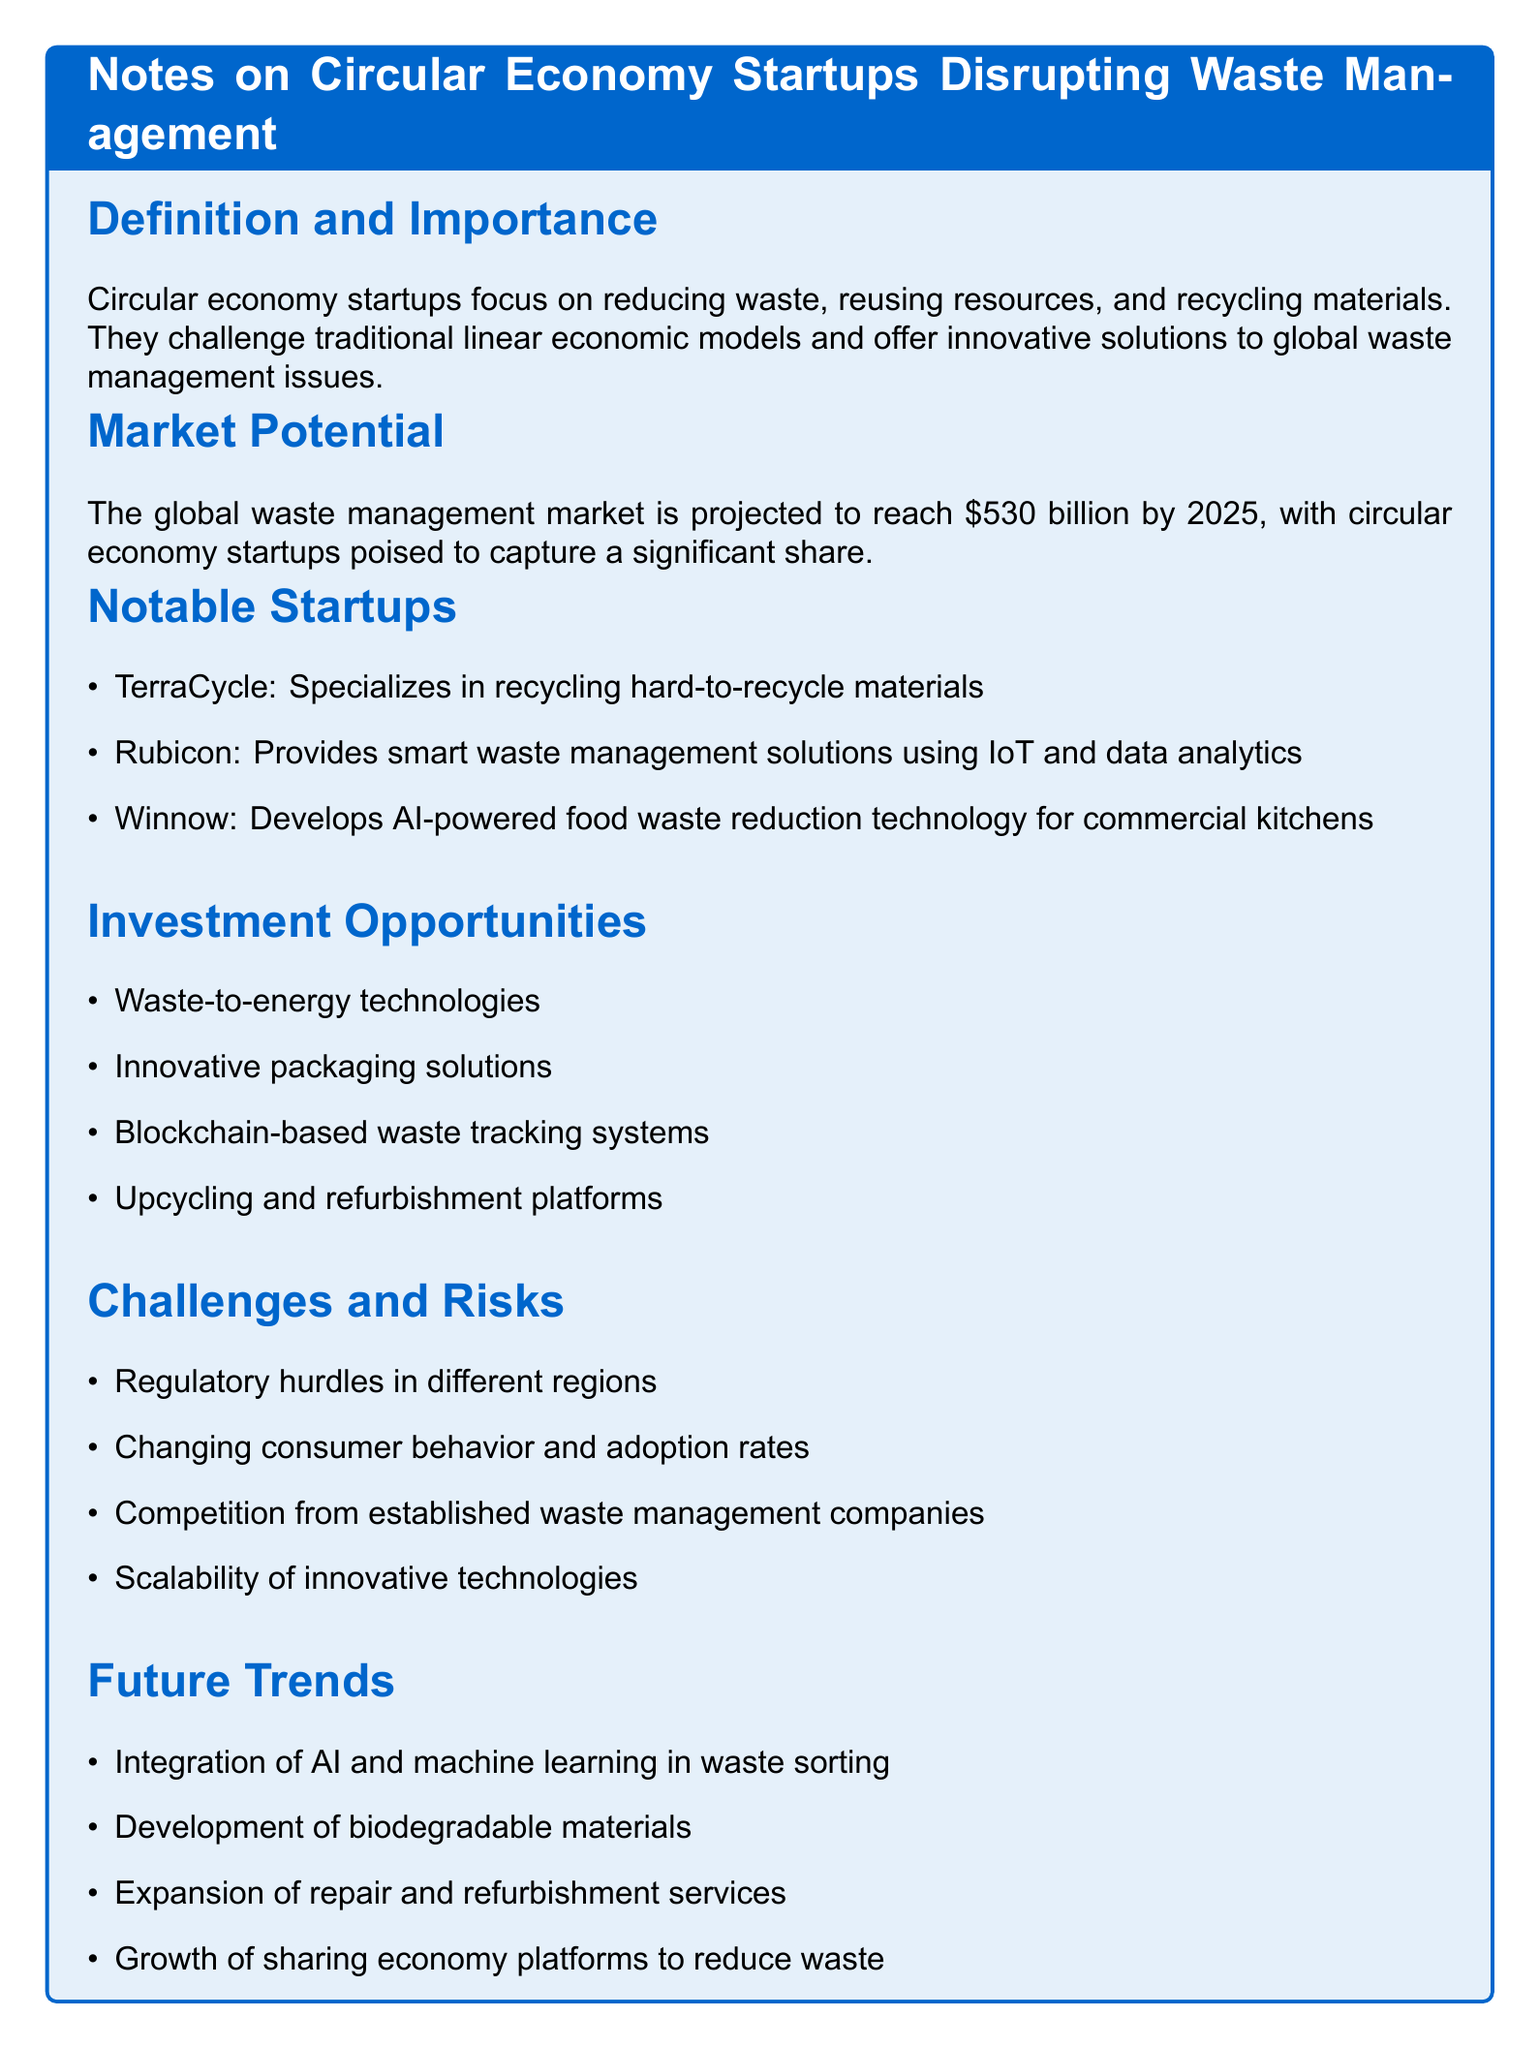what is the projected size of the waste management market by 2025? The projected size of the global waste management market is mentioned in the document, which is $530 billion.
Answer: $530 billion which startup specializes in recycling hard-to-recycle materials? The document lists notable startups, one of which specializes in recycling hard-to-recycle materials, that is TerraCycle.
Answer: TerraCycle name one investment opportunity mentioned in the document. The document outlines various investment opportunities, including waste-to-energy technologies as one of them.
Answer: Waste-to-energy technologies what is a challenge faced by circular economy startups? The document provides a list of challenges, one of which is regulatory hurdles in different regions.
Answer: Regulatory hurdles what technology is being integrated into waste sorting according to future trends? The future trends section highlights the integration of AI and machine learning in waste sorting.
Answer: AI and machine learning 